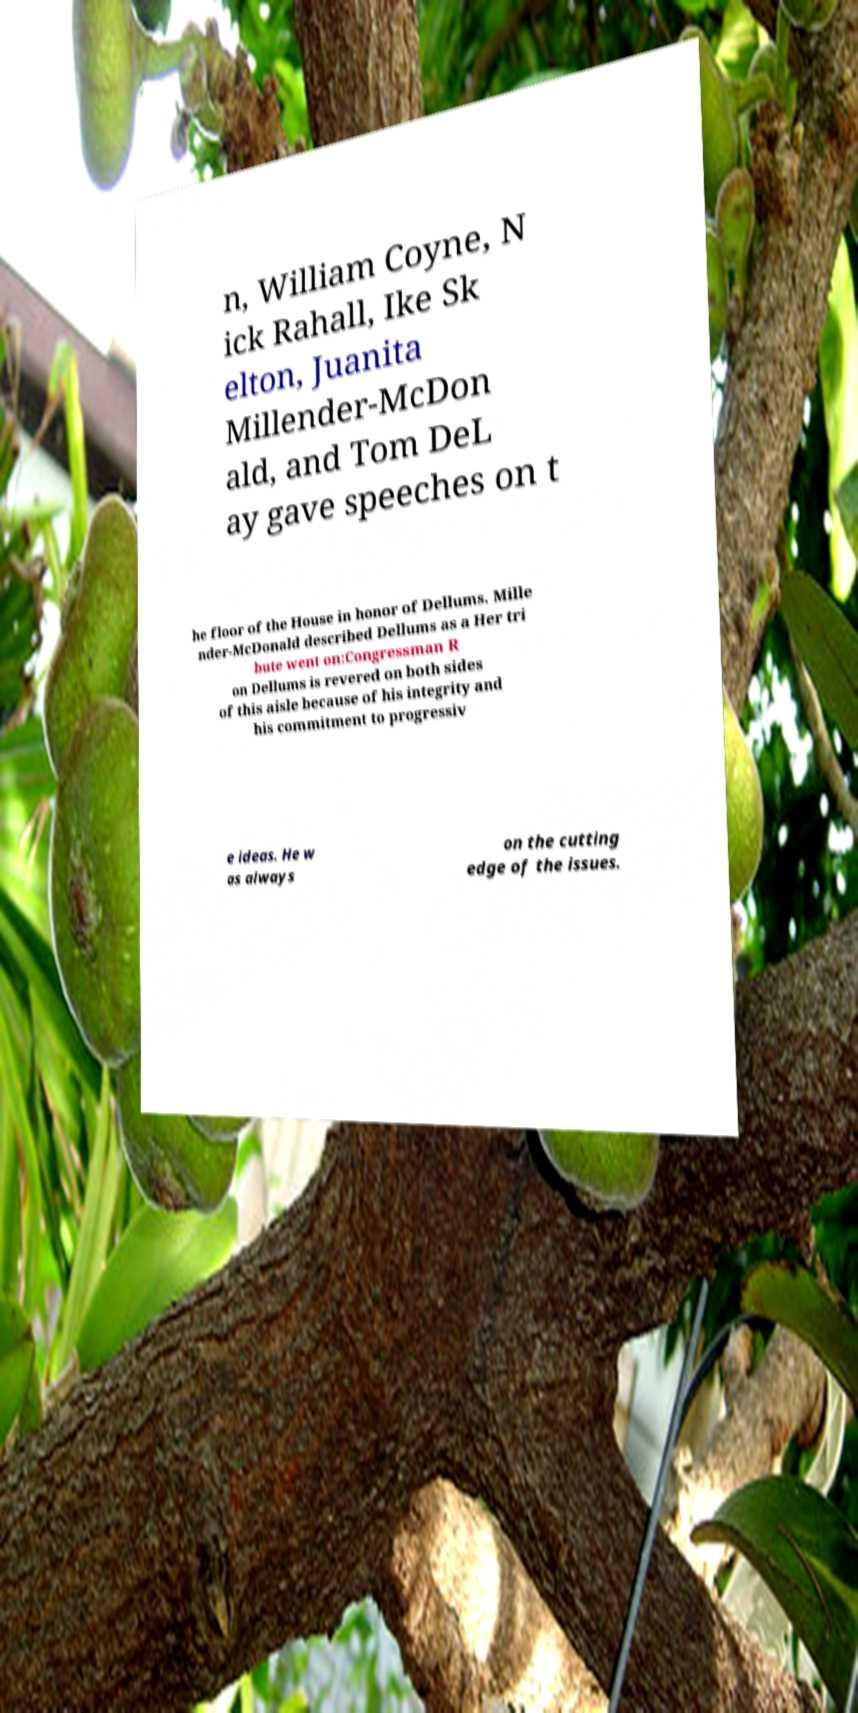I need the written content from this picture converted into text. Can you do that? n, William Coyne, N ick Rahall, Ike Sk elton, Juanita Millender-McDon ald, and Tom DeL ay gave speeches on t he floor of the House in honor of Dellums. Mille nder-McDonald described Dellums as a Her tri bute went on:Congressman R on Dellums is revered on both sides of this aisle because of his integrity and his commitment to progressiv e ideas. He w as always on the cutting edge of the issues. 